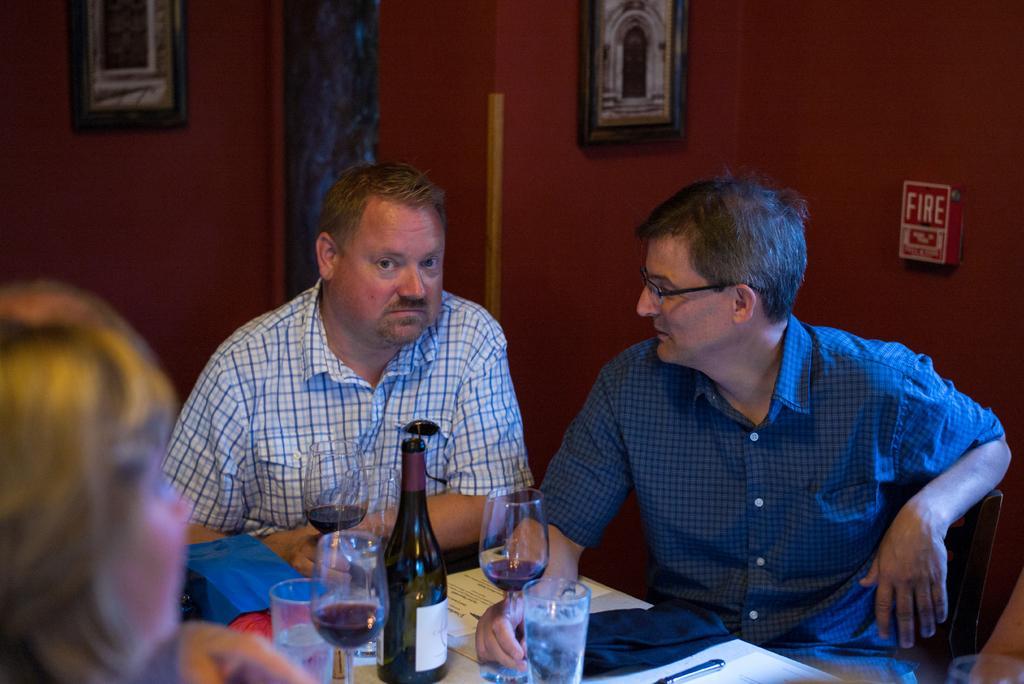Please provide a concise description of this image. In the image we can see there are people who are sitting on chair and on table there is red wine bottle and in the wine glass the red wine is filled. 